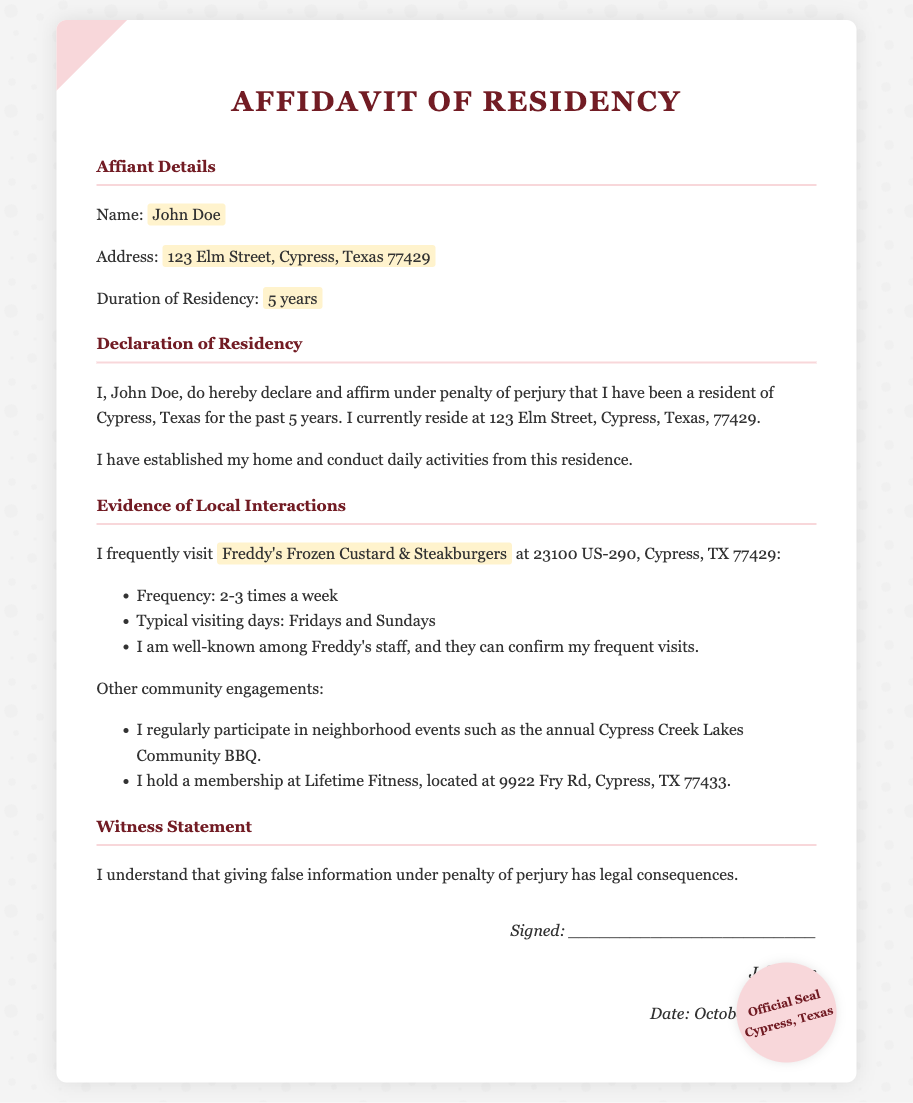What is the name of the affiant? The affiant's name is provided in the document under the "Affiant Details" section.
Answer: John Doe What is the affiant's address? The address is specified within the "Affiant Details" section of the document.
Answer: 123 Elm Street, Cypress, Texas 77429 How long has the affiant lived in Cypress? The duration of residency is mentioned in the "Affiant Details" section.
Answer: 5 years What is the frequency of visits to Freddy's? The frequency of visits is explicitly stated in the "Evidence of Local Interactions" section.
Answer: 2-3 times a week On which days does the affiant typically visit Freddy's? Typical visiting days are outlined in the "Evidence of Local Interactions" section of the document.
Answer: Fridays and Sundays What community event does the affiant participate in? The document includes information about community engagements in the "Evidence of Local Interactions" section.
Answer: Cypress Creek Lakes Community BBQ What is the date of signing for the affidavit? The signing date can be found in the "signature" section of the document.
Answer: October 10, 2023 What organization is mentioned as having confirmed the affiant's visits? The specific organization is noted in the "Evidence of Local Interactions" section of the document.
Answer: Freddy's Frozen Custard & Steakburgers What legal consequence is mentioned regarding false information? This information is indicated in the "Witness Statement" portion of the document.
Answer: legal consequences 